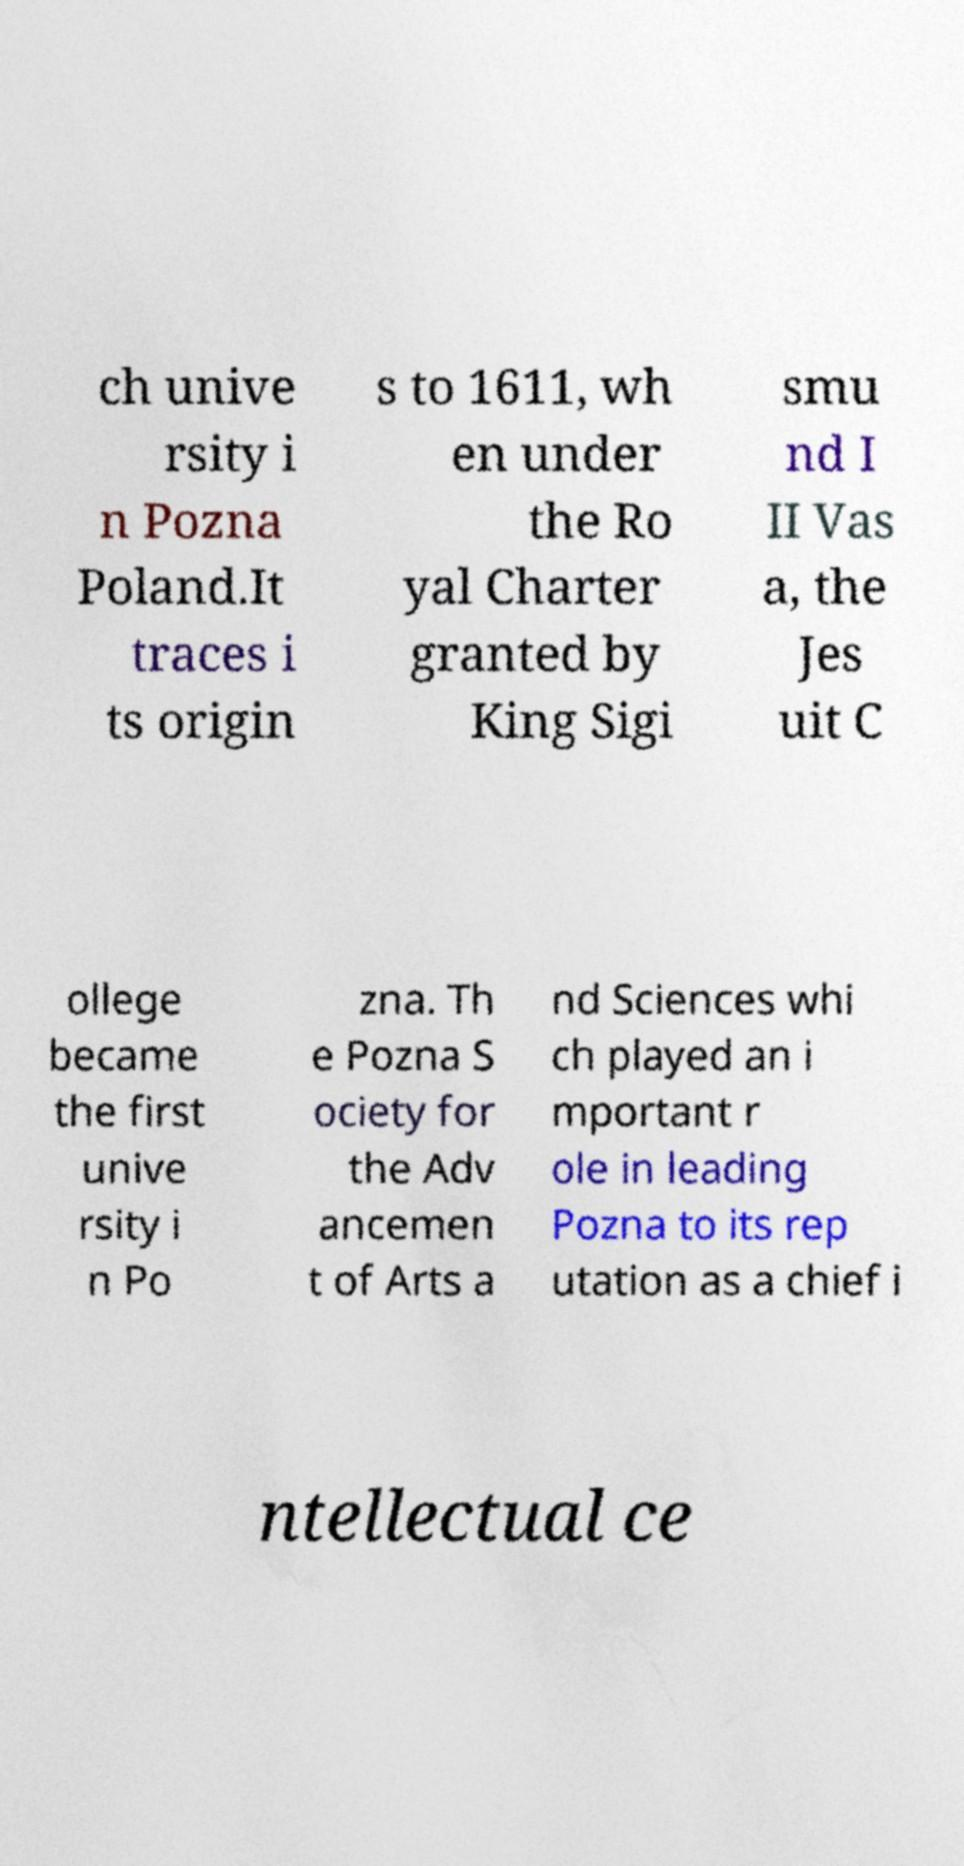Please identify and transcribe the text found in this image. ch unive rsity i n Pozna Poland.It traces i ts origin s to 1611, wh en under the Ro yal Charter granted by King Sigi smu nd I II Vas a, the Jes uit C ollege became the first unive rsity i n Po zna. Th e Pozna S ociety for the Adv ancemen t of Arts a nd Sciences whi ch played an i mportant r ole in leading Pozna to its rep utation as a chief i ntellectual ce 